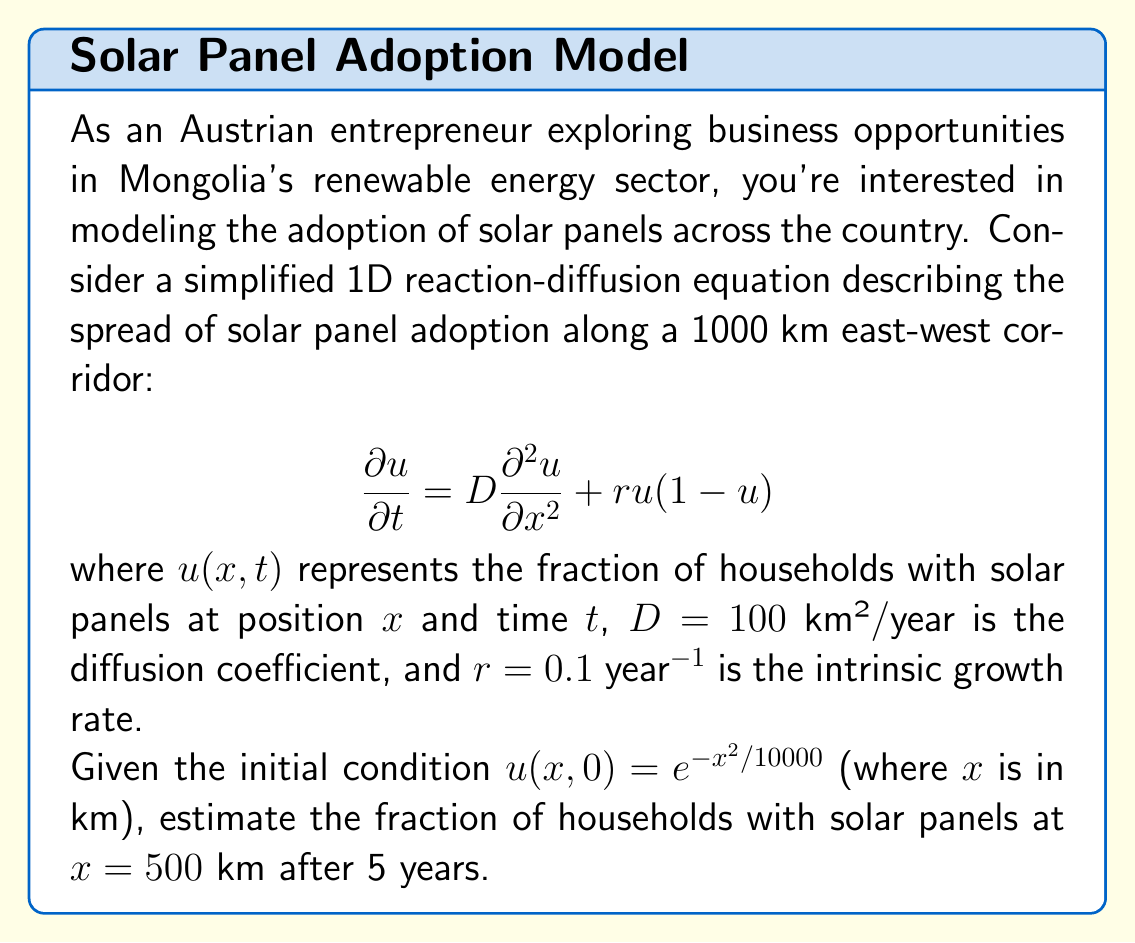Show me your answer to this math problem. To solve this problem, we'll use the Fisher-KPP equation, which is a type of reaction-diffusion equation. The solution can be approximated using the traveling wave solution method:

1) The wave speed of the traveling wave solution is given by:
   $$c = 2\sqrt{Dr}$$

2) Substituting the given values:
   $$c = 2\sqrt{100 \cdot 0.1} = 2\sqrt{10} \approx 6.32$$ km/year

3) The wave front position after time $t$ is approximately:
   $$x_f = ct = 6.32 \cdot 5 = 31.6$$ km

4) The initial condition has its peak at $x=0$, and we're interested in the point $x=500$ km. 

5) After 5 years, the wave front will have moved 31.6 km. Since this is much less than 500 km, the adoption rate at 500 km will still be close to the initial condition.

6) We can estimate the adoption rate by evaluating the initial condition at $x=500$:
   $$u(500,0) = e^{-500^2/10000} = e^{-25} \approx 1.39 \times 10^{-11}$$

7) This value is extremely small, indicating that after 5 years, the adoption of solar panels will have barely reached the 500 km mark.

Therefore, the fraction of households with solar panels at $x=500$ km after 5 years will be approximately $1.39 \times 10^{-11}$, or effectively zero for practical purposes.
Answer: $1.39 \times 10^{-11}$ 